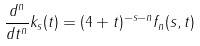<formula> <loc_0><loc_0><loc_500><loc_500>\frac { d ^ { n } } { d t ^ { n } } k _ { s } ( t ) = ( 4 + t ) ^ { - s - n } f _ { n } ( s , t )</formula> 